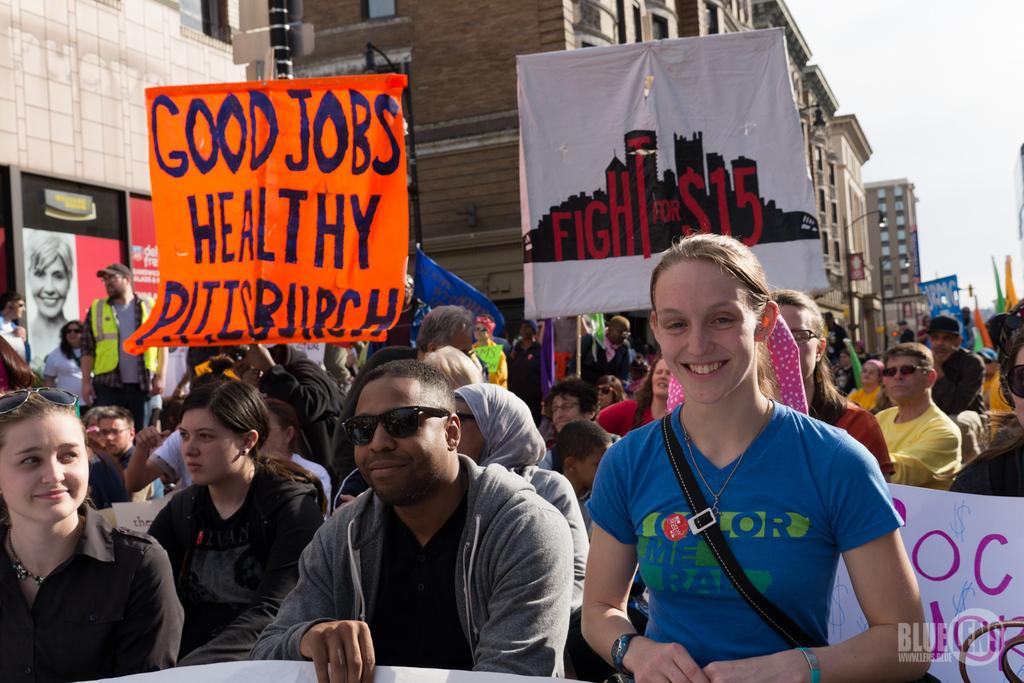What are the people on the road doing in the image? The people on the road are holding posters and placards in the image. What can be seen in the background of the image? There are buildings visible in the image. What is visible above the people and buildings in the image? The sky is visible in the image. What type of beetle can be seen crawling on the ear of one of the people holding a poster in the image? There is no beetle or ear visible in the image; the people are holding posters and placards, and there are buildings and the sky in the background. 